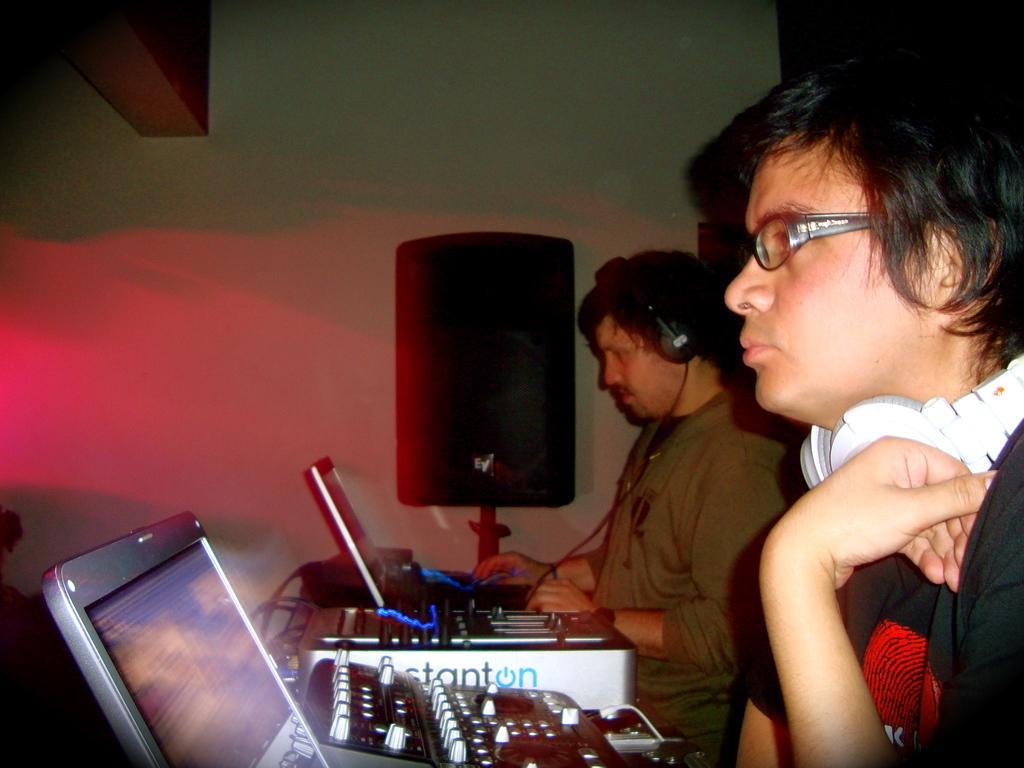Could you give a brief overview of what you see in this image? In this image in the front of there are persons. On the right side in the center there are musical instruments. In the background there is a wall and in front of the all there is an object which is black in colour. On the left side at the top there is a shelf. 